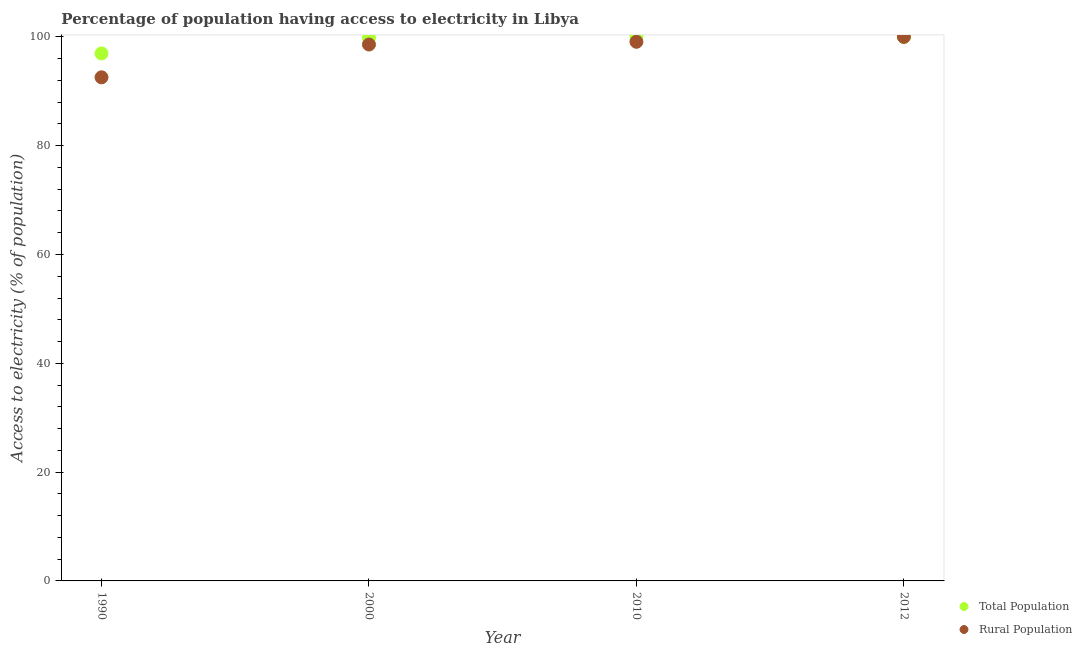Is the number of dotlines equal to the number of legend labels?
Provide a succinct answer. Yes. What is the percentage of population having access to electricity in 1990?
Offer a terse response. 96.96. Across all years, what is the maximum percentage of rural population having access to electricity?
Ensure brevity in your answer.  100. Across all years, what is the minimum percentage of rural population having access to electricity?
Your response must be concise. 92.57. In which year was the percentage of rural population having access to electricity maximum?
Give a very brief answer. 2012. What is the total percentage of rural population having access to electricity in the graph?
Provide a short and direct response. 390.27. What is the difference between the percentage of rural population having access to electricity in 2000 and that in 2012?
Your answer should be very brief. -1.4. What is the difference between the percentage of population having access to electricity in 2010 and the percentage of rural population having access to electricity in 1990?
Provide a succinct answer. 7.43. What is the average percentage of population having access to electricity per year?
Your response must be concise. 99.19. In the year 2000, what is the difference between the percentage of rural population having access to electricity and percentage of population having access to electricity?
Your answer should be very brief. -1.2. What is the ratio of the percentage of rural population having access to electricity in 1990 to that in 2000?
Your answer should be very brief. 0.94. Is the percentage of population having access to electricity in 1990 less than that in 2000?
Keep it short and to the point. Yes. What is the difference between the highest and the lowest percentage of population having access to electricity?
Your answer should be very brief. 3.04. Is the percentage of rural population having access to electricity strictly greater than the percentage of population having access to electricity over the years?
Your response must be concise. No. How many dotlines are there?
Your answer should be compact. 2. What is the difference between two consecutive major ticks on the Y-axis?
Your response must be concise. 20. Does the graph contain grids?
Keep it short and to the point. No. Where does the legend appear in the graph?
Keep it short and to the point. Bottom right. What is the title of the graph?
Provide a succinct answer. Percentage of population having access to electricity in Libya. Does "Personal remittances" appear as one of the legend labels in the graph?
Make the answer very short. No. What is the label or title of the Y-axis?
Provide a short and direct response. Access to electricity (% of population). What is the Access to electricity (% of population) in Total Population in 1990?
Your response must be concise. 96.96. What is the Access to electricity (% of population) of Rural Population in 1990?
Your answer should be very brief. 92.57. What is the Access to electricity (% of population) of Total Population in 2000?
Your answer should be very brief. 99.8. What is the Access to electricity (% of population) of Rural Population in 2000?
Offer a terse response. 98.6. What is the Access to electricity (% of population) in Rural Population in 2010?
Offer a terse response. 99.1. What is the Access to electricity (% of population) of Rural Population in 2012?
Provide a short and direct response. 100. Across all years, what is the maximum Access to electricity (% of population) of Total Population?
Ensure brevity in your answer.  100. Across all years, what is the maximum Access to electricity (% of population) of Rural Population?
Keep it short and to the point. 100. Across all years, what is the minimum Access to electricity (% of population) of Total Population?
Your answer should be compact. 96.96. Across all years, what is the minimum Access to electricity (% of population) of Rural Population?
Your answer should be very brief. 92.57. What is the total Access to electricity (% of population) of Total Population in the graph?
Your response must be concise. 396.76. What is the total Access to electricity (% of population) of Rural Population in the graph?
Offer a terse response. 390.27. What is the difference between the Access to electricity (% of population) in Total Population in 1990 and that in 2000?
Ensure brevity in your answer.  -2.84. What is the difference between the Access to electricity (% of population) of Rural Population in 1990 and that in 2000?
Provide a short and direct response. -6.03. What is the difference between the Access to electricity (% of population) in Total Population in 1990 and that in 2010?
Provide a short and direct response. -3.04. What is the difference between the Access to electricity (% of population) of Rural Population in 1990 and that in 2010?
Provide a short and direct response. -6.53. What is the difference between the Access to electricity (% of population) of Total Population in 1990 and that in 2012?
Offer a very short reply. -3.04. What is the difference between the Access to electricity (% of population) in Rural Population in 1990 and that in 2012?
Your answer should be very brief. -7.43. What is the difference between the Access to electricity (% of population) of Total Population in 2000 and that in 2010?
Offer a very short reply. -0.2. What is the difference between the Access to electricity (% of population) of Rural Population in 2000 and that in 2010?
Offer a very short reply. -0.5. What is the difference between the Access to electricity (% of population) in Rural Population in 2000 and that in 2012?
Offer a terse response. -1.4. What is the difference between the Access to electricity (% of population) in Rural Population in 2010 and that in 2012?
Make the answer very short. -0.9. What is the difference between the Access to electricity (% of population) in Total Population in 1990 and the Access to electricity (% of population) in Rural Population in 2000?
Your response must be concise. -1.64. What is the difference between the Access to electricity (% of population) of Total Population in 1990 and the Access to electricity (% of population) of Rural Population in 2010?
Keep it short and to the point. -2.14. What is the difference between the Access to electricity (% of population) of Total Population in 1990 and the Access to electricity (% of population) of Rural Population in 2012?
Make the answer very short. -3.04. What is the difference between the Access to electricity (% of population) of Total Population in 2000 and the Access to electricity (% of population) of Rural Population in 2012?
Your answer should be very brief. -0.2. What is the average Access to electricity (% of population) in Total Population per year?
Keep it short and to the point. 99.19. What is the average Access to electricity (% of population) of Rural Population per year?
Keep it short and to the point. 97.57. In the year 1990, what is the difference between the Access to electricity (% of population) in Total Population and Access to electricity (% of population) in Rural Population?
Keep it short and to the point. 4.39. In the year 2000, what is the difference between the Access to electricity (% of population) in Total Population and Access to electricity (% of population) in Rural Population?
Your answer should be compact. 1.2. In the year 2010, what is the difference between the Access to electricity (% of population) in Total Population and Access to electricity (% of population) in Rural Population?
Keep it short and to the point. 0.9. What is the ratio of the Access to electricity (% of population) in Total Population in 1990 to that in 2000?
Keep it short and to the point. 0.97. What is the ratio of the Access to electricity (% of population) of Rural Population in 1990 to that in 2000?
Keep it short and to the point. 0.94. What is the ratio of the Access to electricity (% of population) of Total Population in 1990 to that in 2010?
Provide a succinct answer. 0.97. What is the ratio of the Access to electricity (% of population) of Rural Population in 1990 to that in 2010?
Your answer should be very brief. 0.93. What is the ratio of the Access to electricity (% of population) of Total Population in 1990 to that in 2012?
Make the answer very short. 0.97. What is the ratio of the Access to electricity (% of population) in Rural Population in 1990 to that in 2012?
Keep it short and to the point. 0.93. What is the ratio of the Access to electricity (% of population) of Total Population in 2000 to that in 2010?
Provide a succinct answer. 1. What is the ratio of the Access to electricity (% of population) in Rural Population in 2000 to that in 2010?
Ensure brevity in your answer.  0.99. What is the ratio of the Access to electricity (% of population) in Total Population in 2000 to that in 2012?
Your answer should be compact. 1. What is the ratio of the Access to electricity (% of population) in Rural Population in 2000 to that in 2012?
Keep it short and to the point. 0.99. What is the ratio of the Access to electricity (% of population) of Total Population in 2010 to that in 2012?
Your response must be concise. 1. What is the ratio of the Access to electricity (% of population) in Rural Population in 2010 to that in 2012?
Provide a succinct answer. 0.99. What is the difference between the highest and the second highest Access to electricity (% of population) in Total Population?
Offer a terse response. 0. What is the difference between the highest and the second highest Access to electricity (% of population) in Rural Population?
Your response must be concise. 0.9. What is the difference between the highest and the lowest Access to electricity (% of population) of Total Population?
Offer a very short reply. 3.04. What is the difference between the highest and the lowest Access to electricity (% of population) in Rural Population?
Make the answer very short. 7.43. 